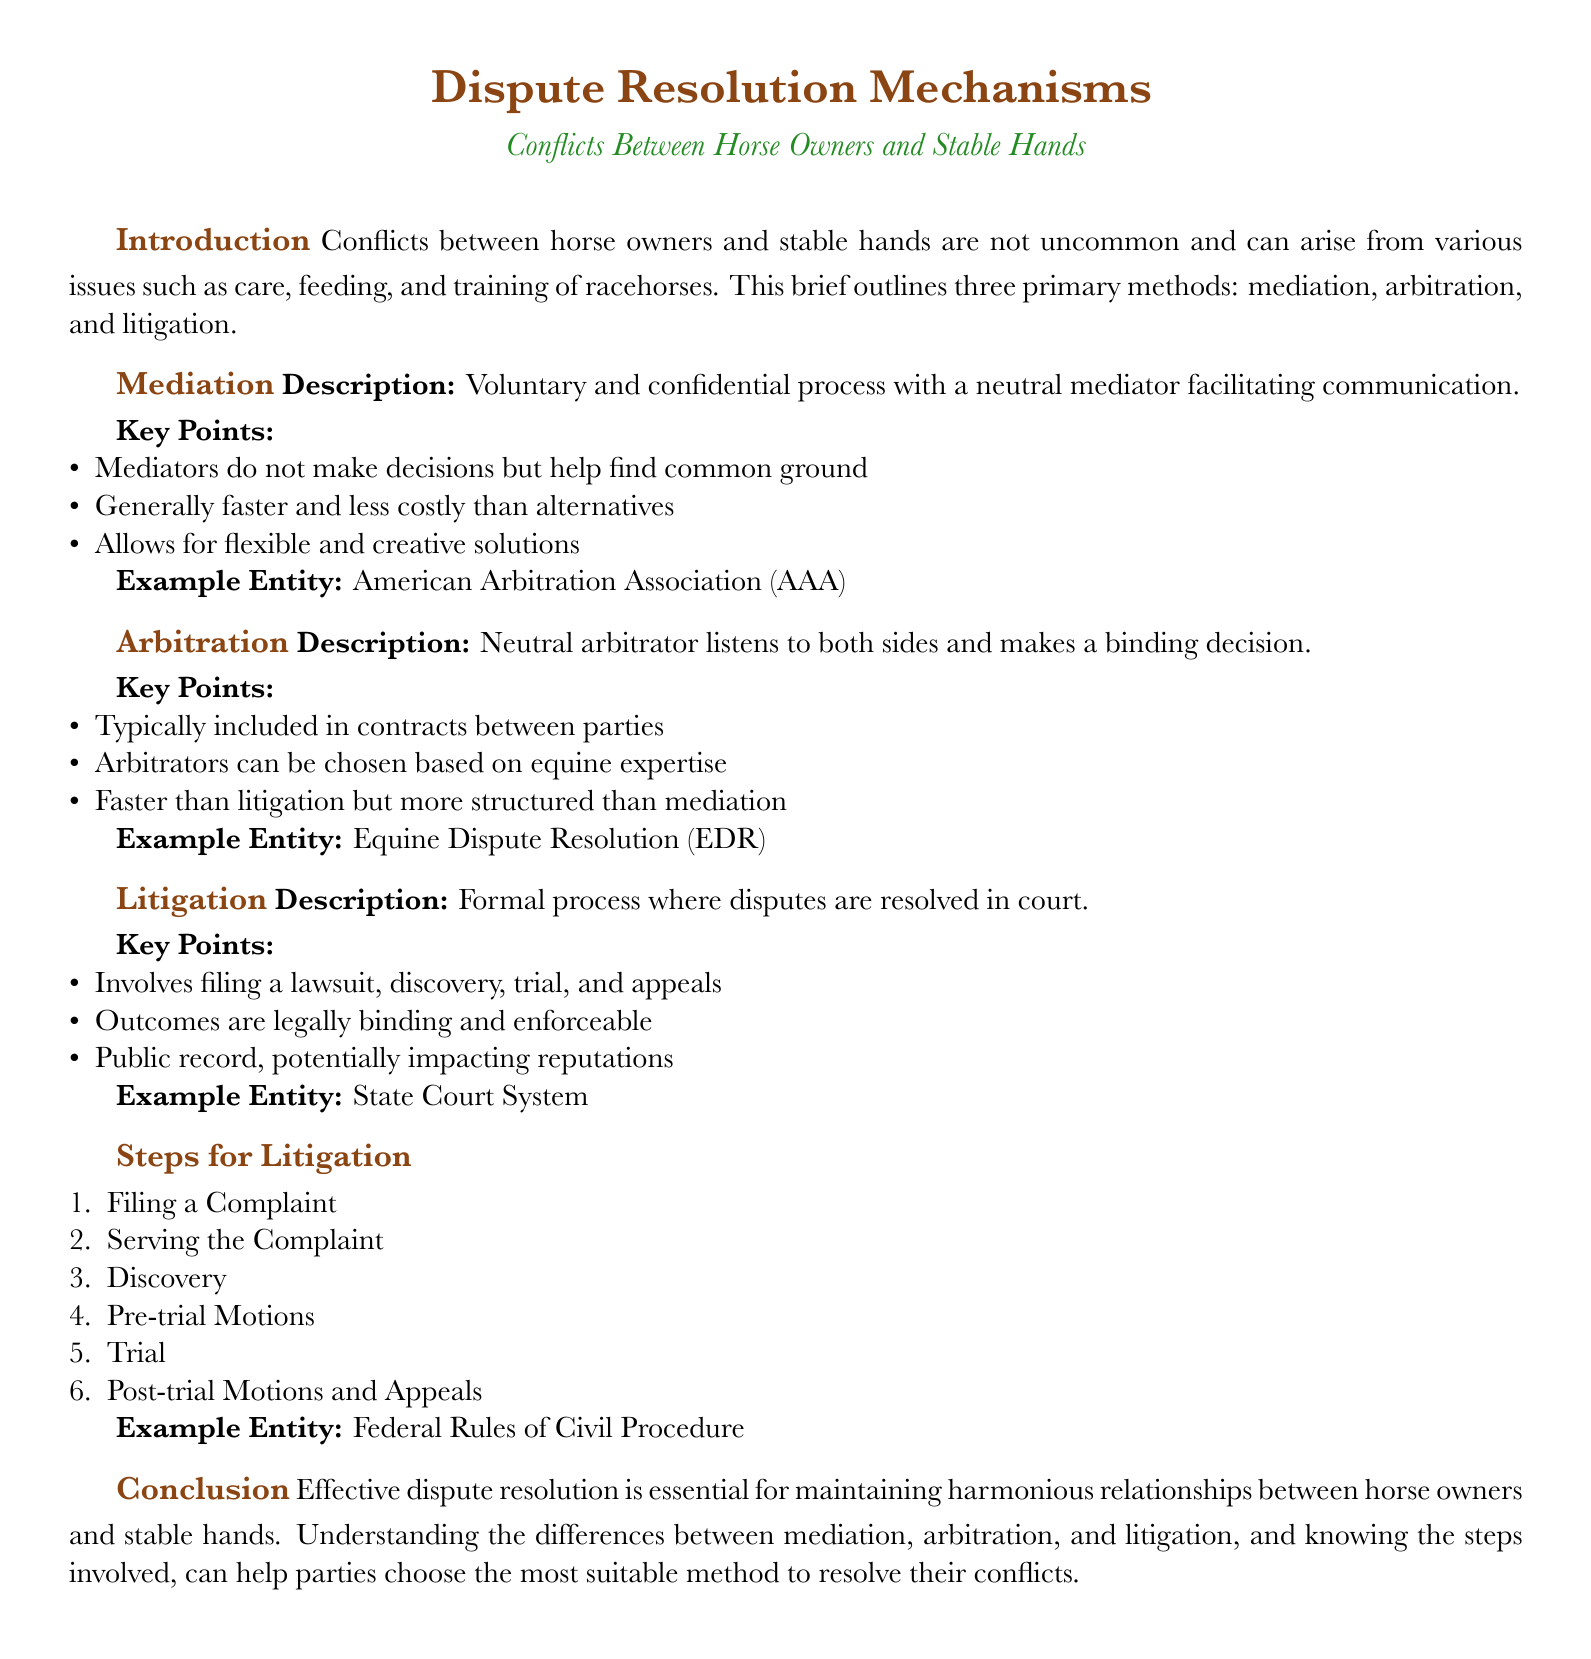What is the primary issue addressed in the document? The document addresses conflicts that arise between horse owners and stable hands concerning care, feeding, and training of racehorses.
Answer: Conflicts What is the main characteristic of mediation? Mediation is described as a voluntary and confidential process with a neutral mediator facilitating communication.
Answer: Voluntary and confidential What organization is mentioned as an example entity for mediation? The document provides the American Arbitration Association (AAA) as an example entity for mediation.
Answer: American Arbitration Association What is the first step listed in the litigation process? The first step in the litigation process is filing a complaint.
Answer: Filing a Complaint Which dispute resolution mechanism typically results in a legally binding decision? Arbitration results in a binding decision from a neutral arbitrator after listening to both sides.
Answer: Arbitration What key aspect differentiates arbitration from mediation? Arbitration typically involves a neutral arbitrator making a binding decision, while mediation does not.
Answer: Binding decision How many steps are listed in the litigation process? The document lists six steps in the litigation process.
Answer: Six steps What is the public record implication mentioned in litigation? The outcomes of litigation are legally binding and enforceable, and the process creates a public record potentially impacting reputations.
Answer: Public record Which example entity is referenced for litigation in the document? The state court system is given as the example entity for litigation.
Answer: State Court System 